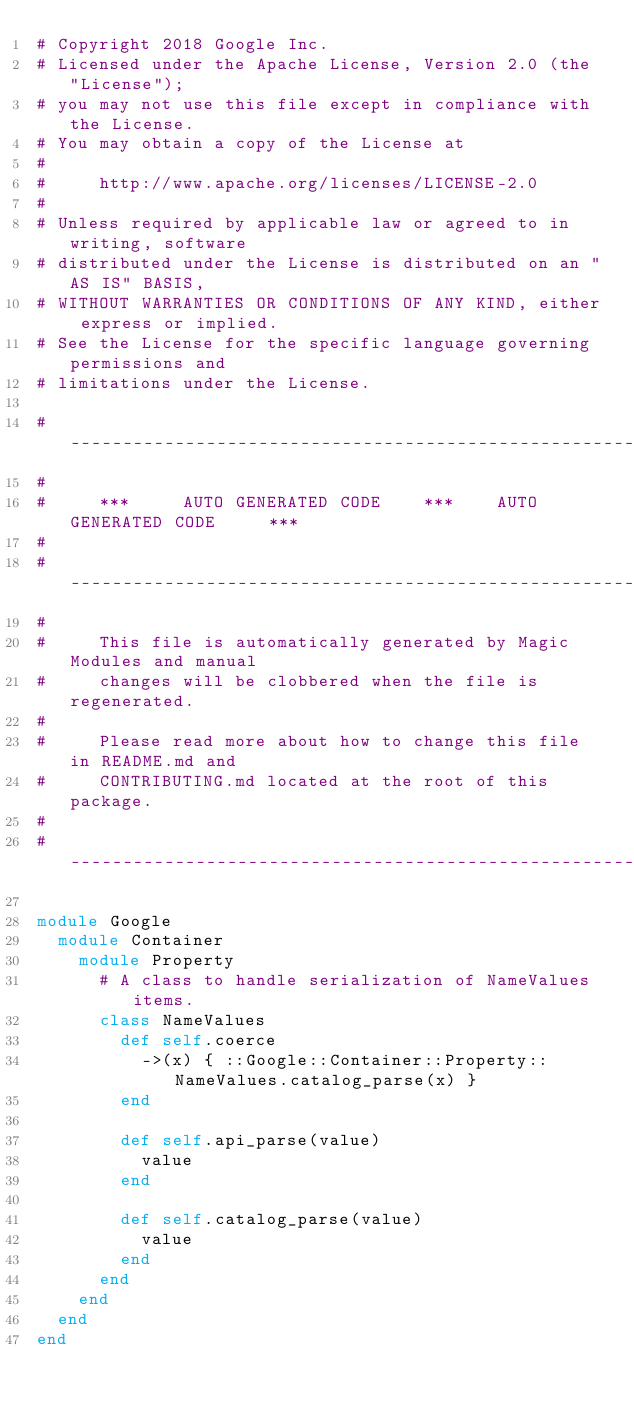Convert code to text. <code><loc_0><loc_0><loc_500><loc_500><_Ruby_># Copyright 2018 Google Inc.
# Licensed under the Apache License, Version 2.0 (the "License");
# you may not use this file except in compliance with the License.
# You may obtain a copy of the License at
#
#     http://www.apache.org/licenses/LICENSE-2.0
#
# Unless required by applicable law or agreed to in writing, software
# distributed under the License is distributed on an "AS IS" BASIS,
# WITHOUT WARRANTIES OR CONDITIONS OF ANY KIND, either express or implied.
# See the License for the specific language governing permissions and
# limitations under the License.

# ----------------------------------------------------------------------------
#
#     ***     AUTO GENERATED CODE    ***    AUTO GENERATED CODE     ***
#
# ----------------------------------------------------------------------------
#
#     This file is automatically generated by Magic Modules and manual
#     changes will be clobbered when the file is regenerated.
#
#     Please read more about how to change this file in README.md and
#     CONTRIBUTING.md located at the root of this package.
#
# ----------------------------------------------------------------------------

module Google
  module Container
    module Property
      # A class to handle serialization of NameValues items.
      class NameValues
        def self.coerce
          ->(x) { ::Google::Container::Property::NameValues.catalog_parse(x) }
        end

        def self.api_parse(value)
          value
        end

        def self.catalog_parse(value)
          value
        end
      end
    end
  end
end
</code> 